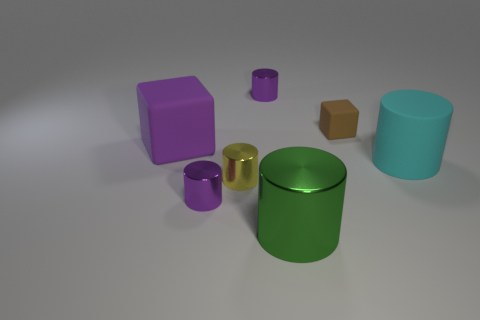How many purple cylinders must be subtracted to get 1 purple cylinders? 1 Subtract all yellow spheres. How many purple cylinders are left? 2 Subtract all big green cylinders. How many cylinders are left? 4 Add 1 brown objects. How many objects exist? 8 Subtract all cyan cylinders. How many cylinders are left? 4 Subtract all yellow cylinders. Subtract all cyan cubes. How many cylinders are left? 4 Subtract all cubes. How many objects are left? 5 Add 7 large matte cylinders. How many large matte cylinders are left? 8 Add 2 big cyan cylinders. How many big cyan cylinders exist? 3 Subtract 0 gray spheres. How many objects are left? 7 